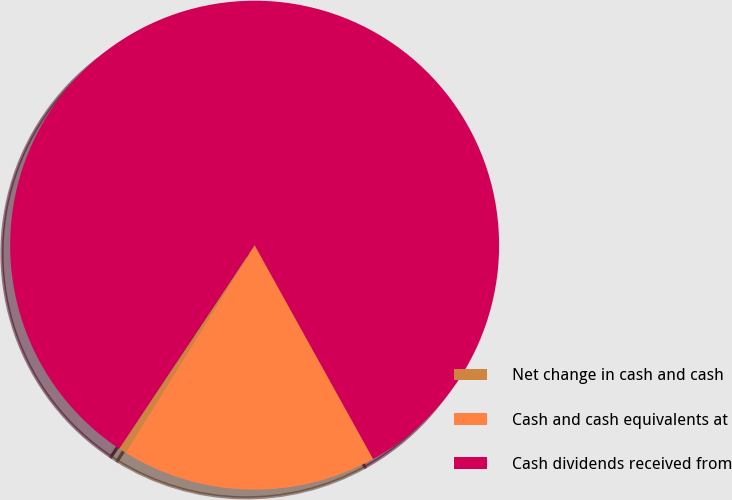<chart> <loc_0><loc_0><loc_500><loc_500><pie_chart><fcel>Net change in cash and cash<fcel>Cash and cash equivalents at<fcel>Cash dividends received from<nl><fcel>0.49%<fcel>16.91%<fcel>82.6%<nl></chart> 